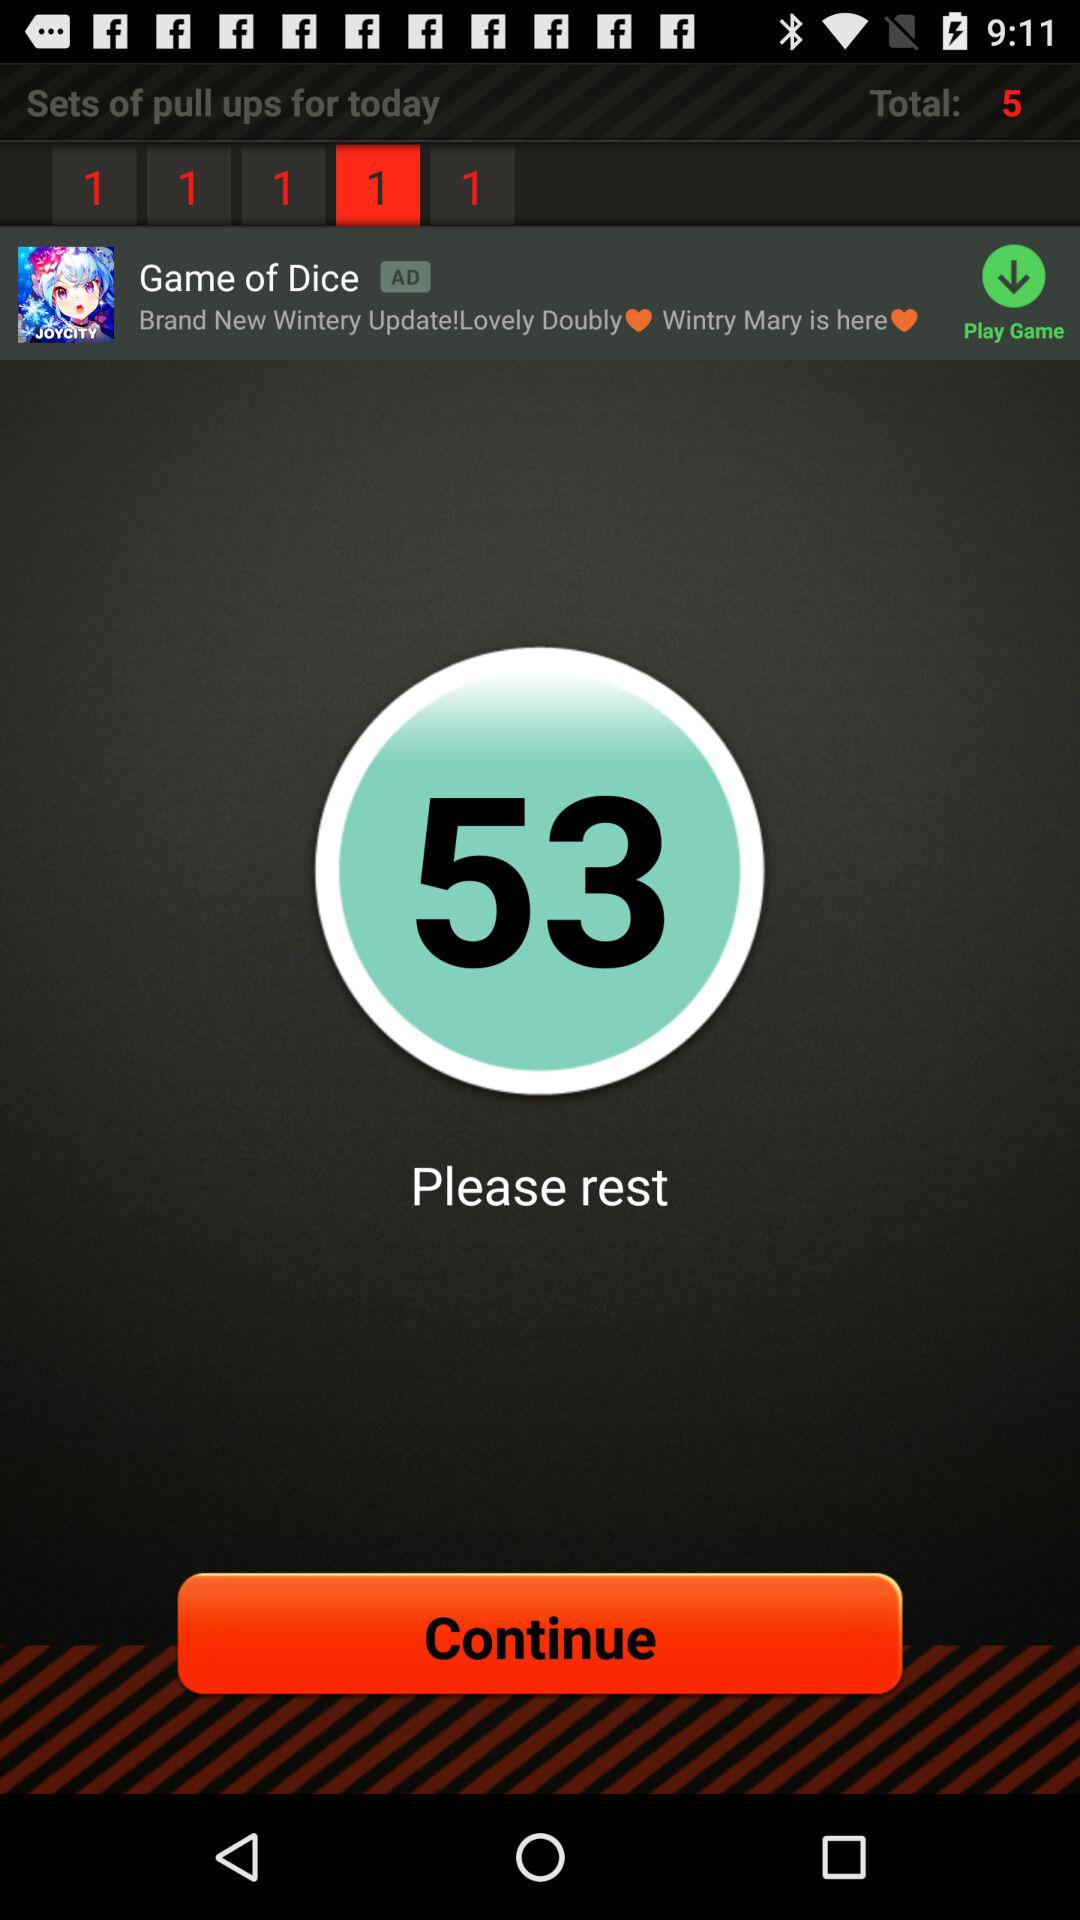Who is resting?
When the provided information is insufficient, respond with <no answer>. <no answer> 